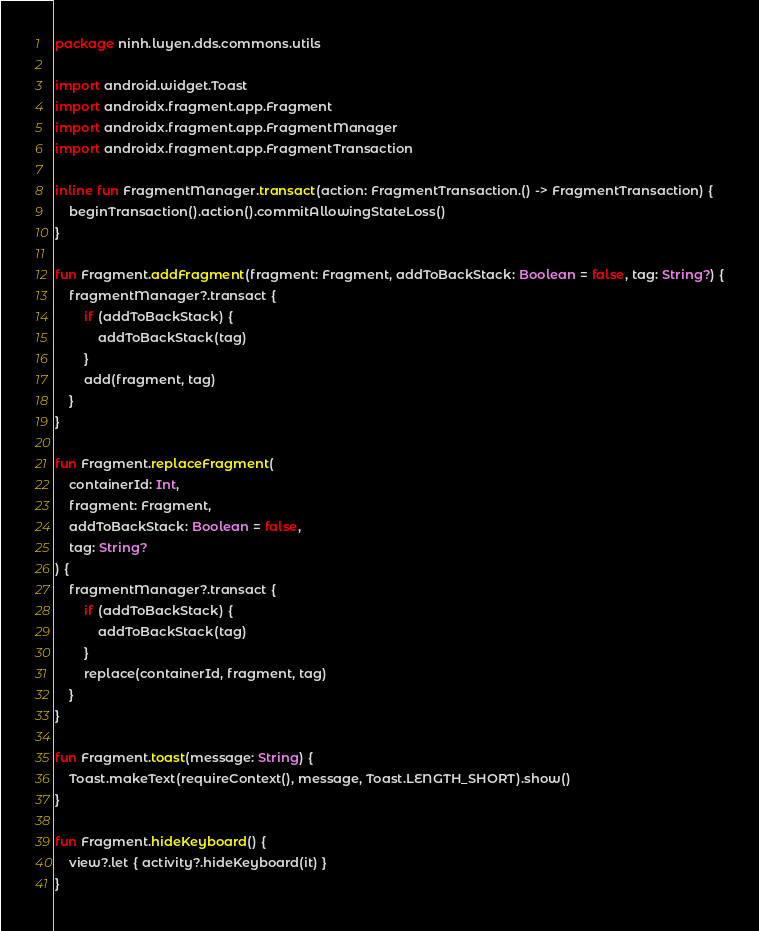Convert code to text. <code><loc_0><loc_0><loc_500><loc_500><_Kotlin_>package ninh.luyen.dds.commons.utils

import android.widget.Toast
import androidx.fragment.app.Fragment
import androidx.fragment.app.FragmentManager
import androidx.fragment.app.FragmentTransaction

inline fun FragmentManager.transact(action: FragmentTransaction.() -> FragmentTransaction) {
    beginTransaction().action().commitAllowingStateLoss()
}

fun Fragment.addFragment(fragment: Fragment, addToBackStack: Boolean = false, tag: String?) {
    fragmentManager?.transact {
        if (addToBackStack) {
            addToBackStack(tag)
        }
        add(fragment, tag)
    }
}

fun Fragment.replaceFragment(
    containerId: Int,
    fragment: Fragment,
    addToBackStack: Boolean = false,
    tag: String?
) {
    fragmentManager?.transact {
        if (addToBackStack) {
            addToBackStack(tag)
        }
        replace(containerId, fragment, tag)
    }
}

fun Fragment.toast(message: String) {
    Toast.makeText(requireContext(), message, Toast.LENGTH_SHORT).show()
}

fun Fragment.hideKeyboard() {
    view?.let { activity?.hideKeyboard(it) }
}</code> 